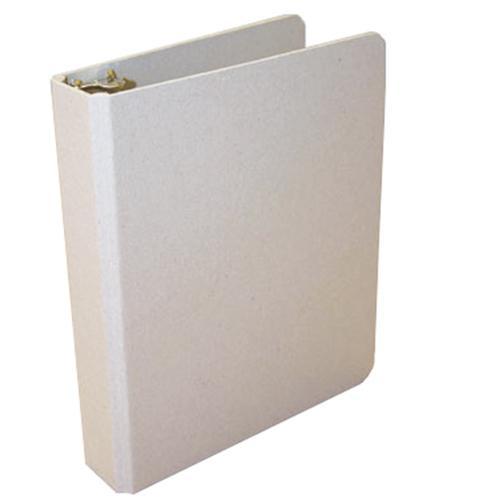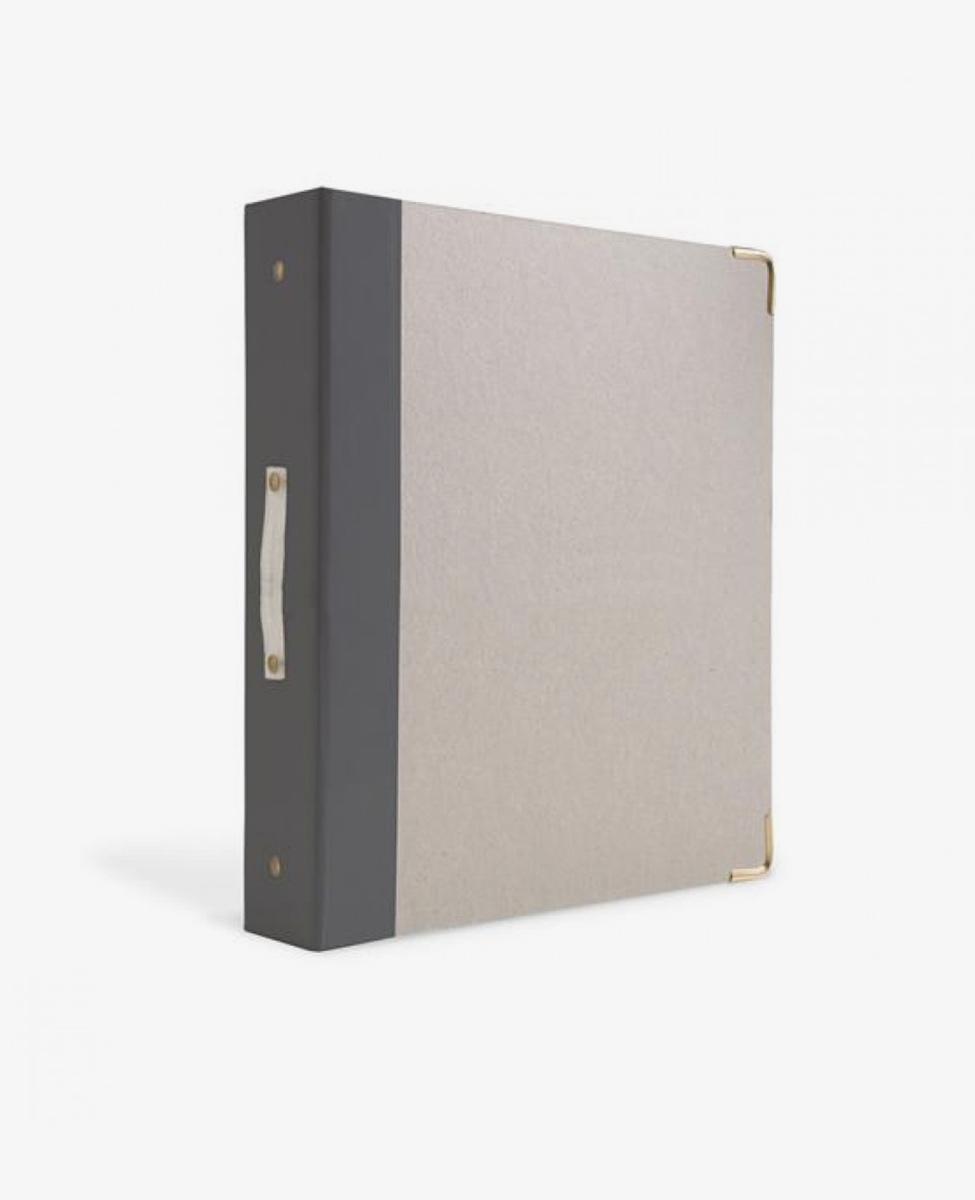The first image is the image on the left, the second image is the image on the right. Assess this claim about the two images: "One of the binders is solid blue.". Correct or not? Answer yes or no. No. The first image is the image on the left, the second image is the image on the right. For the images shown, is this caption "There are at least three binders." true? Answer yes or no. No. 